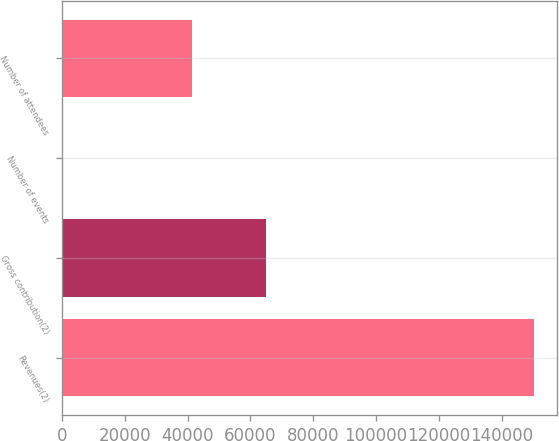<chart> <loc_0><loc_0><loc_500><loc_500><bar_chart><fcel>Revenues(2)<fcel>Gross contribution(2)<fcel>Number of events<fcel>Number of attendees<nl><fcel>150080<fcel>64954<fcel>70<fcel>41352<nl></chart> 